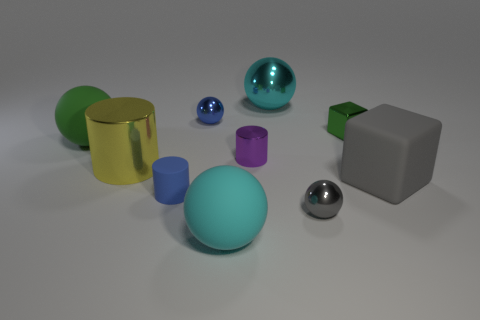There is a rubber cylinder; does it have the same color as the small metal ball behind the large green matte sphere? yes 